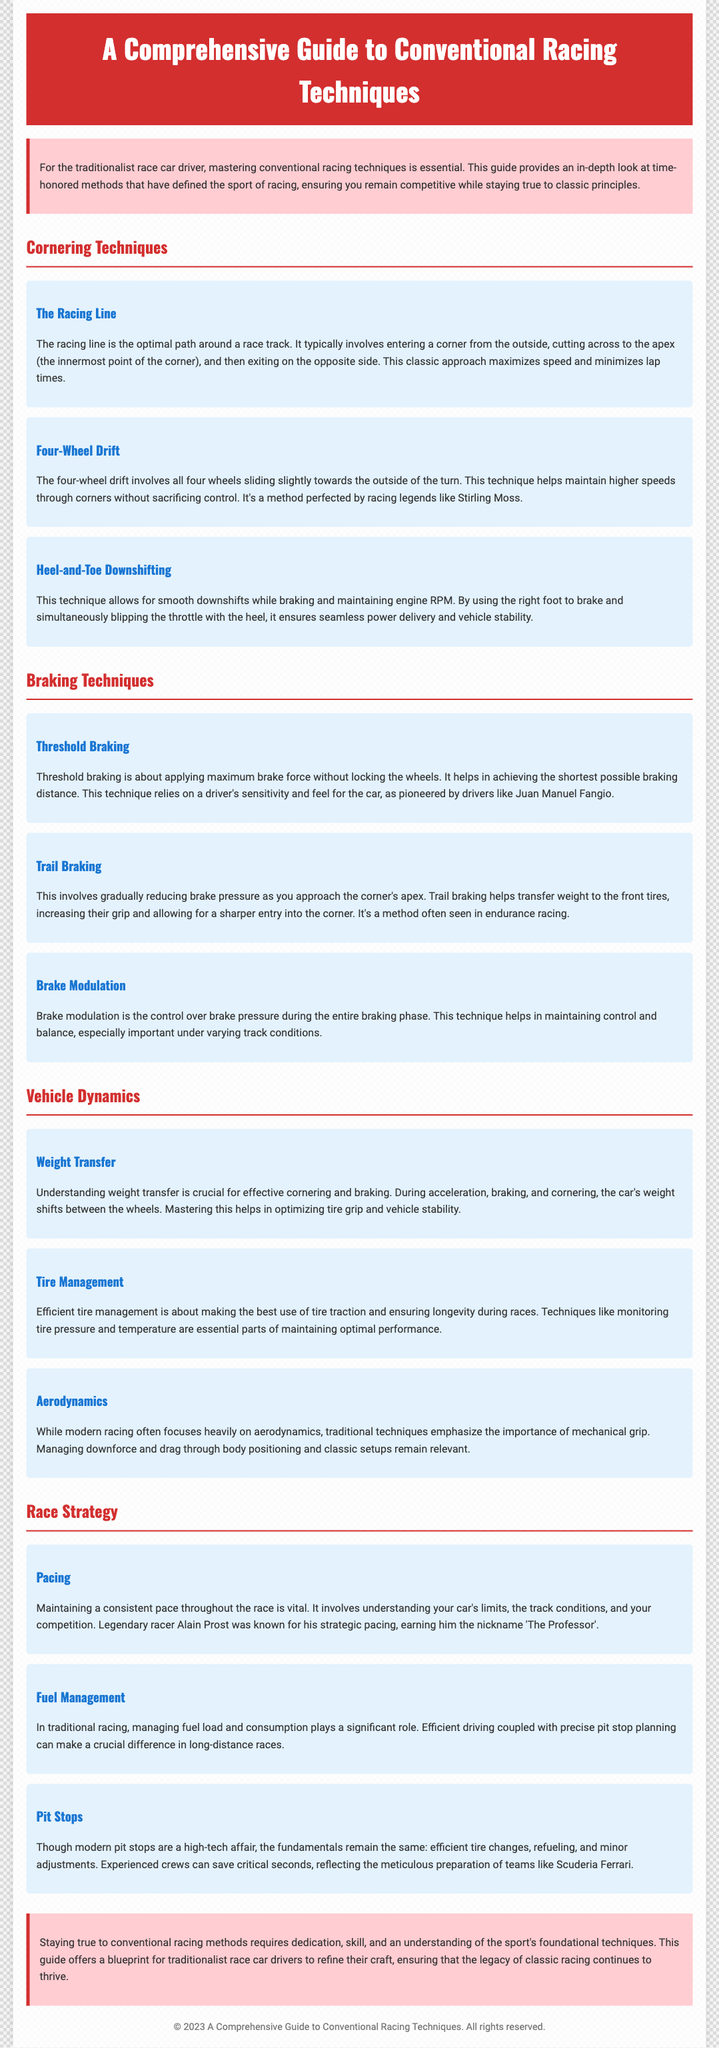What does the guide focus on? The guide focuses on mastering conventional racing techniques essential for traditionalist race car drivers.
Answer: Conventional racing techniques What technique helps maintain higher speeds through corners? The technique involves all four wheels sliding slightly towards the outside of the turn.
Answer: Four-Wheel Drift Who is known for pioneering the threshold braking technique? The driver associated with this technique is a legendary figure in racing history.
Answer: Juan Manuel Fangio What should be managed efficiently for tire performance? The aspect of tire condition that needs careful monitoring affects performance and efficiency.
Answer: Tire pressure and temperature What is the significance of pacing in racing? Pacing is crucial for consistency and involves understanding the car's limits and conditions.
Answer: Consistent pace How does trail braking affect cornering? The technique helps transfer weight to the front tires, thus increasing their grip.
Answer: Increases grip Which racer is associated with the strategic pacing method? This racer is known for his calculated approach and was often called by a specific nickname.
Answer: Alain Prost What are the fundamentals of modern pit stops? The essential actions performed during pit stops include changes and refueling.
Answer: Tire changes and refueling What does brake modulation help maintain? This technique is about controlling a specific aspect during the braking phase, crucial for balance.
Answer: Control and balance 